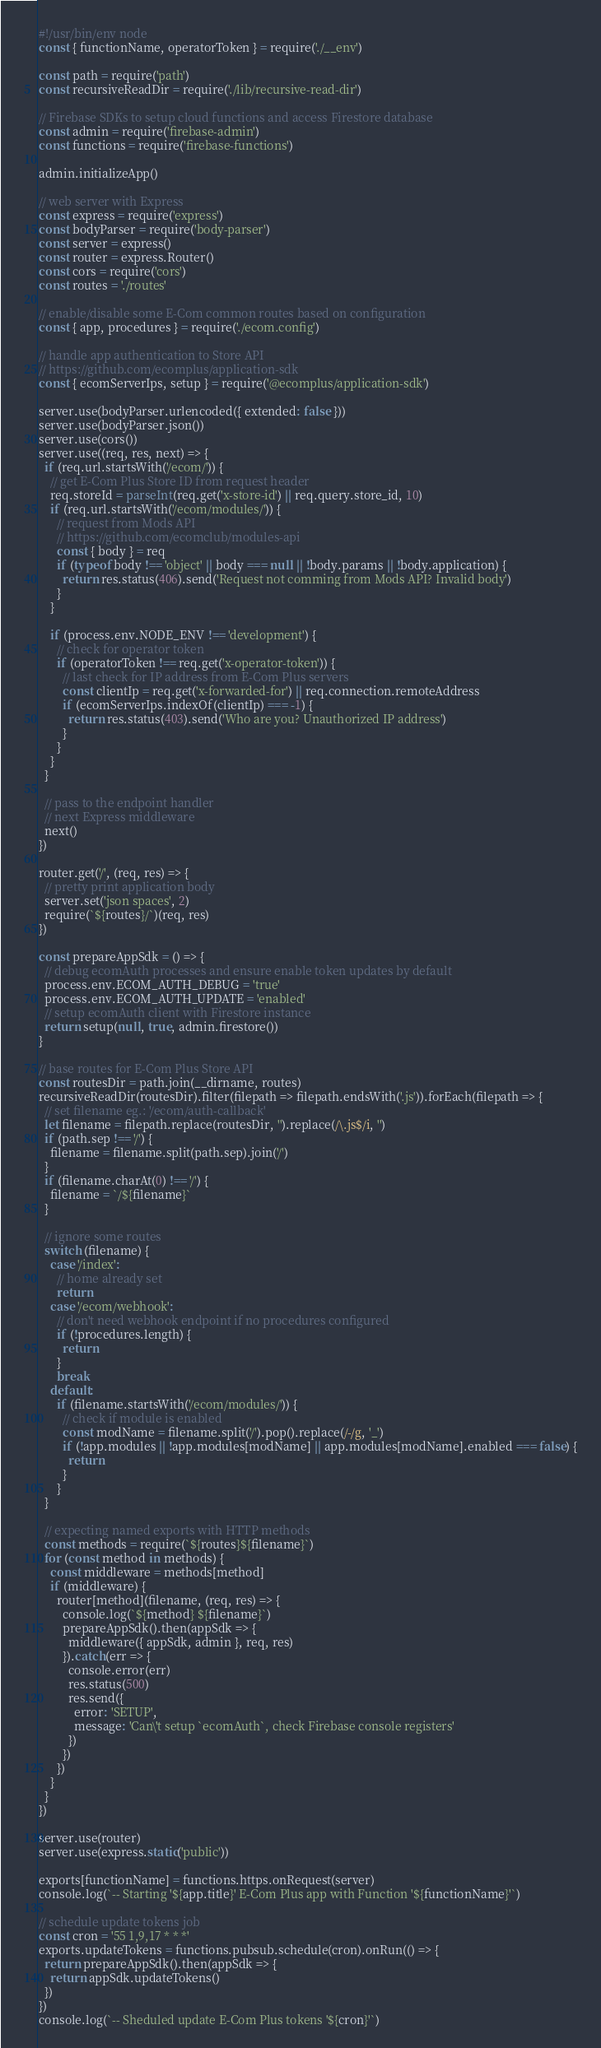Convert code to text. <code><loc_0><loc_0><loc_500><loc_500><_JavaScript_>#!/usr/bin/env node
const { functionName, operatorToken } = require('./__env')

const path = require('path')
const recursiveReadDir = require('./lib/recursive-read-dir')

// Firebase SDKs to setup cloud functions and access Firestore database
const admin = require('firebase-admin')
const functions = require('firebase-functions')

admin.initializeApp()

// web server with Express
const express = require('express')
const bodyParser = require('body-parser')
const server = express()
const router = express.Router()
const cors = require('cors')
const routes = './routes'

// enable/disable some E-Com common routes based on configuration
const { app, procedures } = require('./ecom.config')

// handle app authentication to Store API
// https://github.com/ecomplus/application-sdk
const { ecomServerIps, setup } = require('@ecomplus/application-sdk')

server.use(bodyParser.urlencoded({ extended: false }))
server.use(bodyParser.json())
server.use(cors())
server.use((req, res, next) => {
  if (req.url.startsWith('/ecom/')) {
    // get E-Com Plus Store ID from request header
    req.storeId = parseInt(req.get('x-store-id') || req.query.store_id, 10)
    if (req.url.startsWith('/ecom/modules/')) {
      // request from Mods API
      // https://github.com/ecomclub/modules-api
      const { body } = req
      if (typeof body !== 'object' || body === null || !body.params || !body.application) {
        return res.status(406).send('Request not comming from Mods API? Invalid body')
      }
    }

    if (process.env.NODE_ENV !== 'development') {
      // check for operator token
      if (operatorToken !== req.get('x-operator-token')) {
        // last check for IP address from E-Com Plus servers
        const clientIp = req.get('x-forwarded-for') || req.connection.remoteAddress
        if (ecomServerIps.indexOf(clientIp) === -1) {
          return res.status(403).send('Who are you? Unauthorized IP address')
        }
      }
    }
  }

  // pass to the endpoint handler
  // next Express middleware
  next()
})

router.get('/', (req, res) => {
  // pretty print application body
  server.set('json spaces', 2)
  require(`${routes}/`)(req, res)
})

const prepareAppSdk = () => {
  // debug ecomAuth processes and ensure enable token updates by default
  process.env.ECOM_AUTH_DEBUG = 'true'
  process.env.ECOM_AUTH_UPDATE = 'enabled'
  // setup ecomAuth client with Firestore instance
  return setup(null, true, admin.firestore())
}

// base routes for E-Com Plus Store API
const routesDir = path.join(__dirname, routes)
recursiveReadDir(routesDir).filter(filepath => filepath.endsWith('.js')).forEach(filepath => {
  // set filename eg.: '/ecom/auth-callback'
  let filename = filepath.replace(routesDir, '').replace(/\.js$/i, '')
  if (path.sep !== '/') {
    filename = filename.split(path.sep).join('/')
  }
  if (filename.charAt(0) !== '/') {
    filename = `/${filename}`
  }

  // ignore some routes
  switch (filename) {
    case '/index':
      // home already set
      return
    case '/ecom/webhook':
      // don't need webhook endpoint if no procedures configured
      if (!procedures.length) {
        return
      }
      break
    default:
      if (filename.startsWith('/ecom/modules/')) {
        // check if module is enabled
        const modName = filename.split('/').pop().replace(/-/g, '_')
        if (!app.modules || !app.modules[modName] || app.modules[modName].enabled === false) {
          return
        }
      }
  }

  // expecting named exports with HTTP methods
  const methods = require(`${routes}${filename}`)
  for (const method in methods) {
    const middleware = methods[method]
    if (middleware) {
      router[method](filename, (req, res) => {
        console.log(`${method} ${filename}`)
        prepareAppSdk().then(appSdk => {
          middleware({ appSdk, admin }, req, res)
        }).catch(err => {
          console.error(err)
          res.status(500)
          res.send({
            error: 'SETUP',
            message: 'Can\'t setup `ecomAuth`, check Firebase console registers'
          })
        })
      })
    }
  }
})

server.use(router)
server.use(express.static('public'))

exports[functionName] = functions.https.onRequest(server)
console.log(`-- Starting '${app.title}' E-Com Plus app with Function '${functionName}'`)

// schedule update tokens job
const cron = '55 1,9,17 * * *'
exports.updateTokens = functions.pubsub.schedule(cron).onRun(() => {
  return prepareAppSdk().then(appSdk => {
    return appSdk.updateTokens()
  })
})
console.log(`-- Sheduled update E-Com Plus tokens '${cron}'`)
</code> 